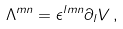<formula> <loc_0><loc_0><loc_500><loc_500>\Lambda ^ { m n } = \epsilon ^ { l m n } \partial _ { l } V \, ,</formula> 